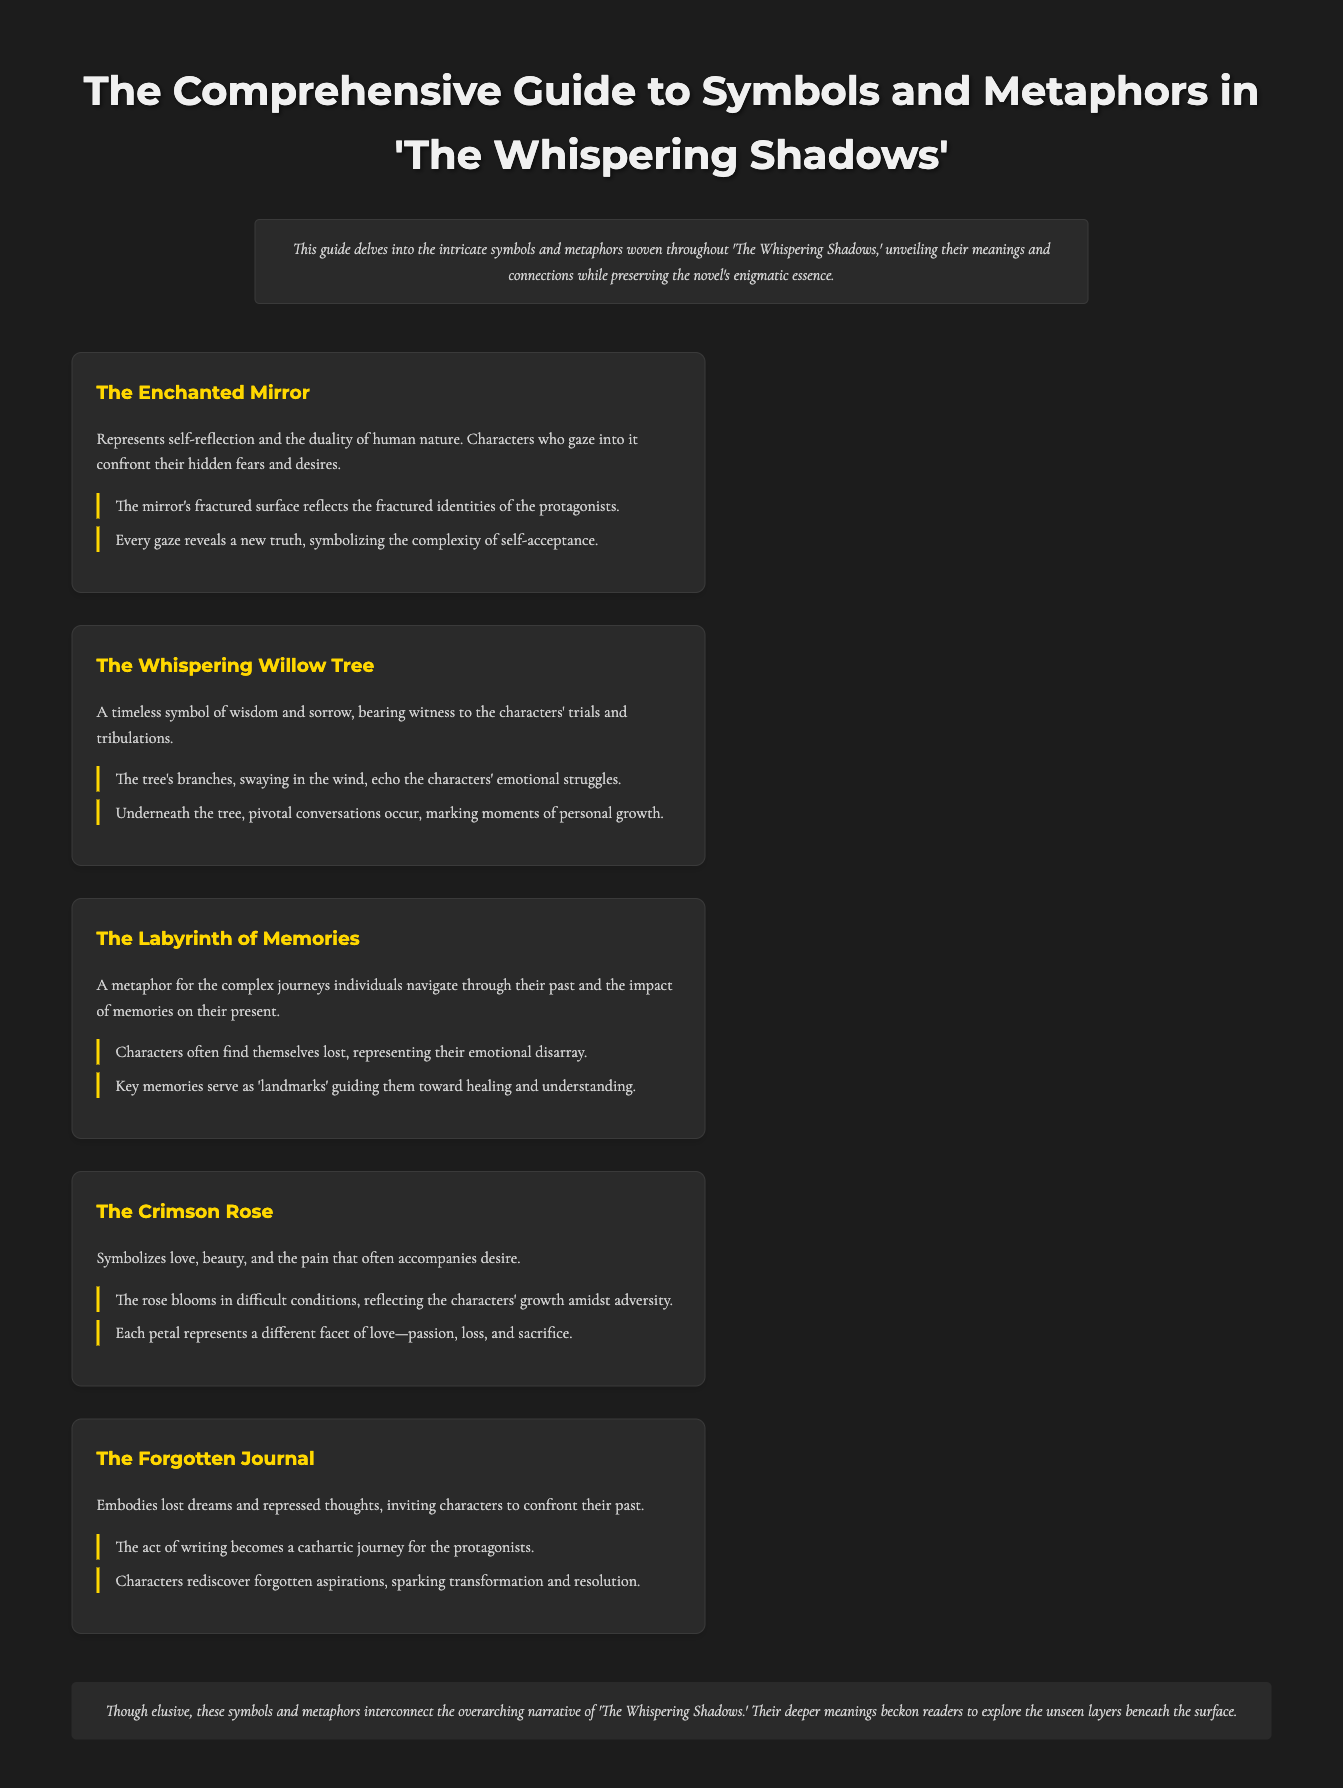What is the title of the novel discussed in the guide? The title mentioned in the document is emphasized at the top of the guide.
Answer: The Whispering Shadows How many symbols are explained in the guide? The document lists five distinct symbols throughout the content.
Answer: Five What does the Enchanted Mirror symbolize? The symbolism of the Enchanted Mirror is explicitly stated in the description of the symbol.
Answer: Self-reflection and duality What does the Forgotten Journal embody? The document describes the Forgotten Journal's meaning in its respective section.
Answer: Lost dreams and repressed thoughts What is the color of the rose mentioned? The color associated with the rose is stated directly in the symbol description.
Answer: Crimson What significant role does the Whispering Willow Tree play? The document outlines the significance of the willow tree in relation to the characters.
Answer: Wisdom and sorrow In which context does the Labyrinth of Memories appear? The context of the Labyrinth of Memories is given in its specific explanation, focusing on individual journeys.
Answer: Complex journeys through the past What do the petals of the Crimson Rose represent? The document lists different aspects mentioned for each petal in the description of the rose.
Answer: Facets of love How are the symbols and metaphors connected in the narrative? The conclusion summarizes the interconnection of the symbols within the overarching narrative.
Answer: Interconnect the overarching narrative 